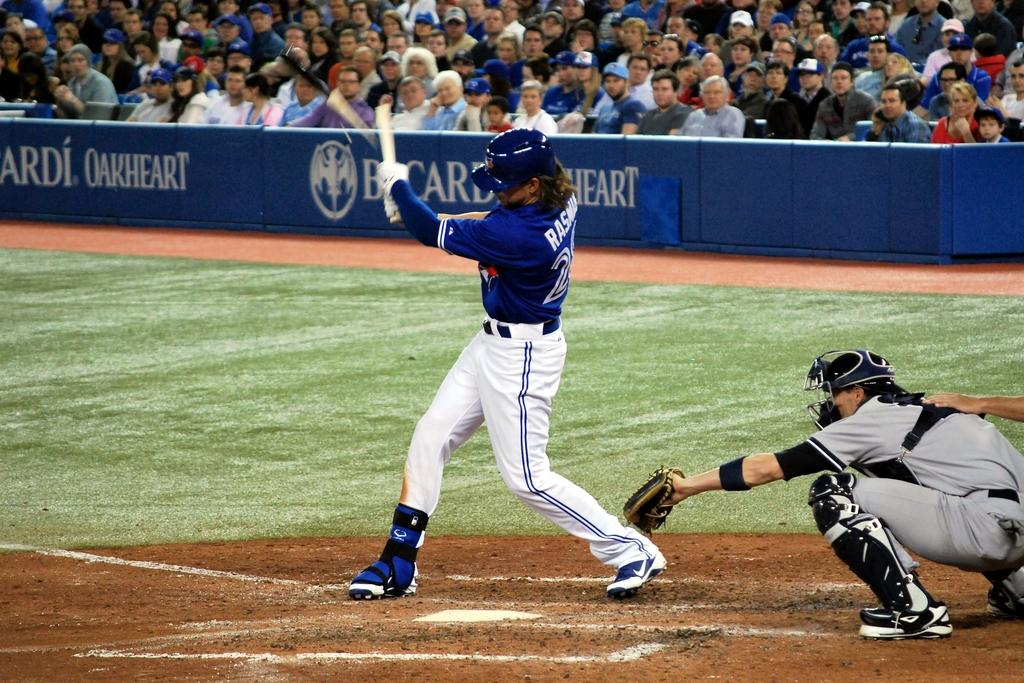<image>
Relay a brief, clear account of the picture shown. A batter swings at a pitch in a baseball game sponsored by Bacardi Oakheart. 